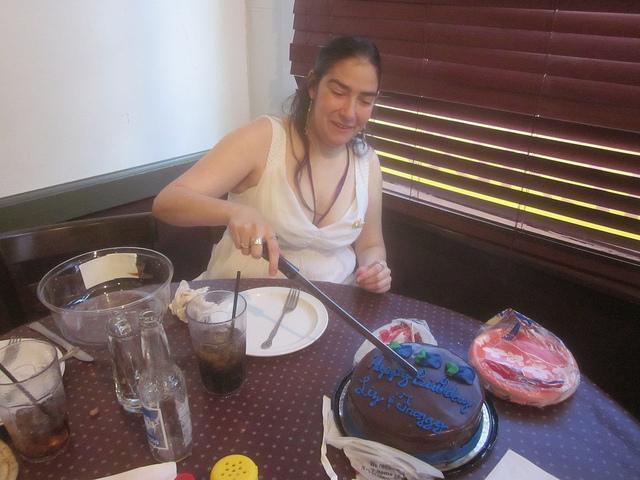How many cups can you see?
Give a very brief answer. 2. How many bottles are in the picture?
Give a very brief answer. 2. 